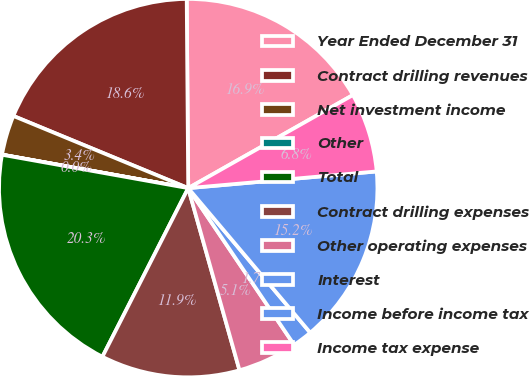Convert chart to OTSL. <chart><loc_0><loc_0><loc_500><loc_500><pie_chart><fcel>Year Ended December 31<fcel>Contract drilling revenues<fcel>Net investment income<fcel>Other<fcel>Total<fcel>Contract drilling expenses<fcel>Other operating expenses<fcel>Interest<fcel>Income before income tax<fcel>Income tax expense<nl><fcel>16.94%<fcel>18.64%<fcel>3.4%<fcel>0.01%<fcel>20.33%<fcel>11.86%<fcel>5.09%<fcel>1.7%<fcel>15.25%<fcel>6.78%<nl></chart> 